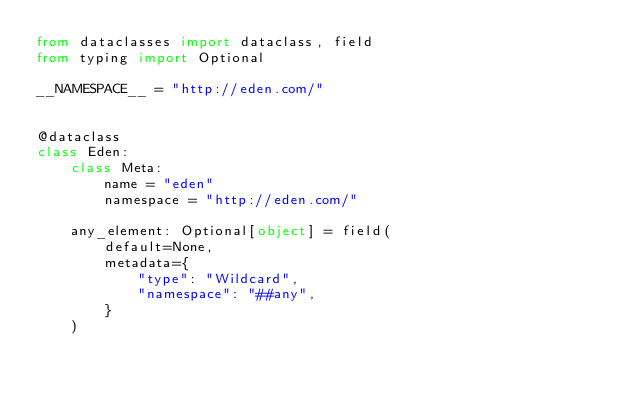Convert code to text. <code><loc_0><loc_0><loc_500><loc_500><_Python_>from dataclasses import dataclass, field
from typing import Optional

__NAMESPACE__ = "http://eden.com/"


@dataclass
class Eden:
    class Meta:
        name = "eden"
        namespace = "http://eden.com/"

    any_element: Optional[object] = field(
        default=None,
        metadata={
            "type": "Wildcard",
            "namespace": "##any",
        }
    )
</code> 